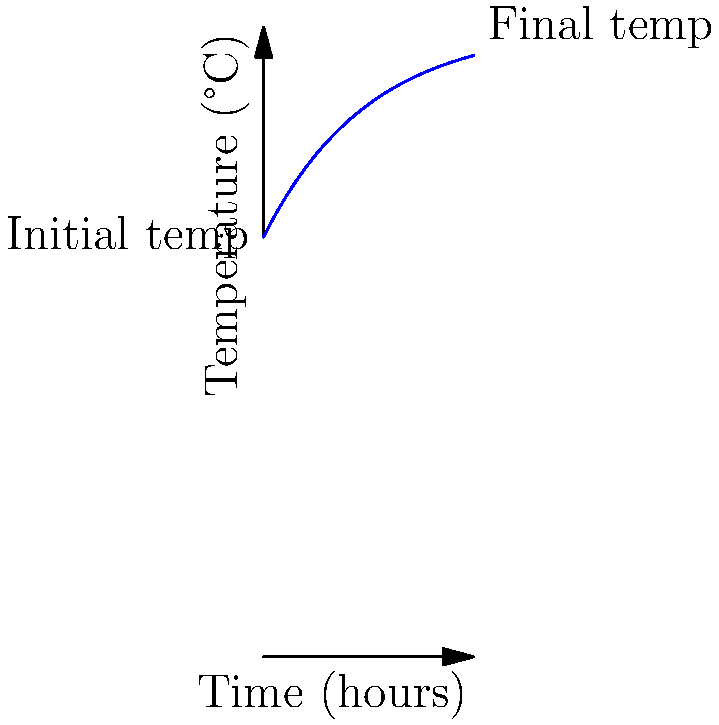A vacation rental's swimming pool is initially at 20°C. The pool heater is turned on, raising the water temperature according to the equation $T(t) = 30 - 10e^{-0.2t}$, where $T$ is the temperature in °C and $t$ is time in hours. How long will it take for the pool to reach 28°C? To solve this problem, we need to follow these steps:

1) We're given the equation: $T(t) = 30 - 10e^{-0.2t}$

2) We want to find $t$ when $T = 28°C$. So, let's substitute this into our equation:

   $28 = 30 - 10e^{-0.2t}$

3) Subtract 30 from both sides:
   
   $-2 = -10e^{-0.2t}$

4) Divide both sides by -10:

   $0.2 = e^{-0.2t}$

5) Take the natural log of both sides:

   $\ln(0.2) = -0.2t$

6) Solve for $t$:

   $t = -\frac{\ln(0.2)}{0.2}$

7) Calculate the result:

   $t \approx 8.05$ hours

Therefore, it will take approximately 8.05 hours for the pool to reach 28°C.
Answer: 8.05 hours 